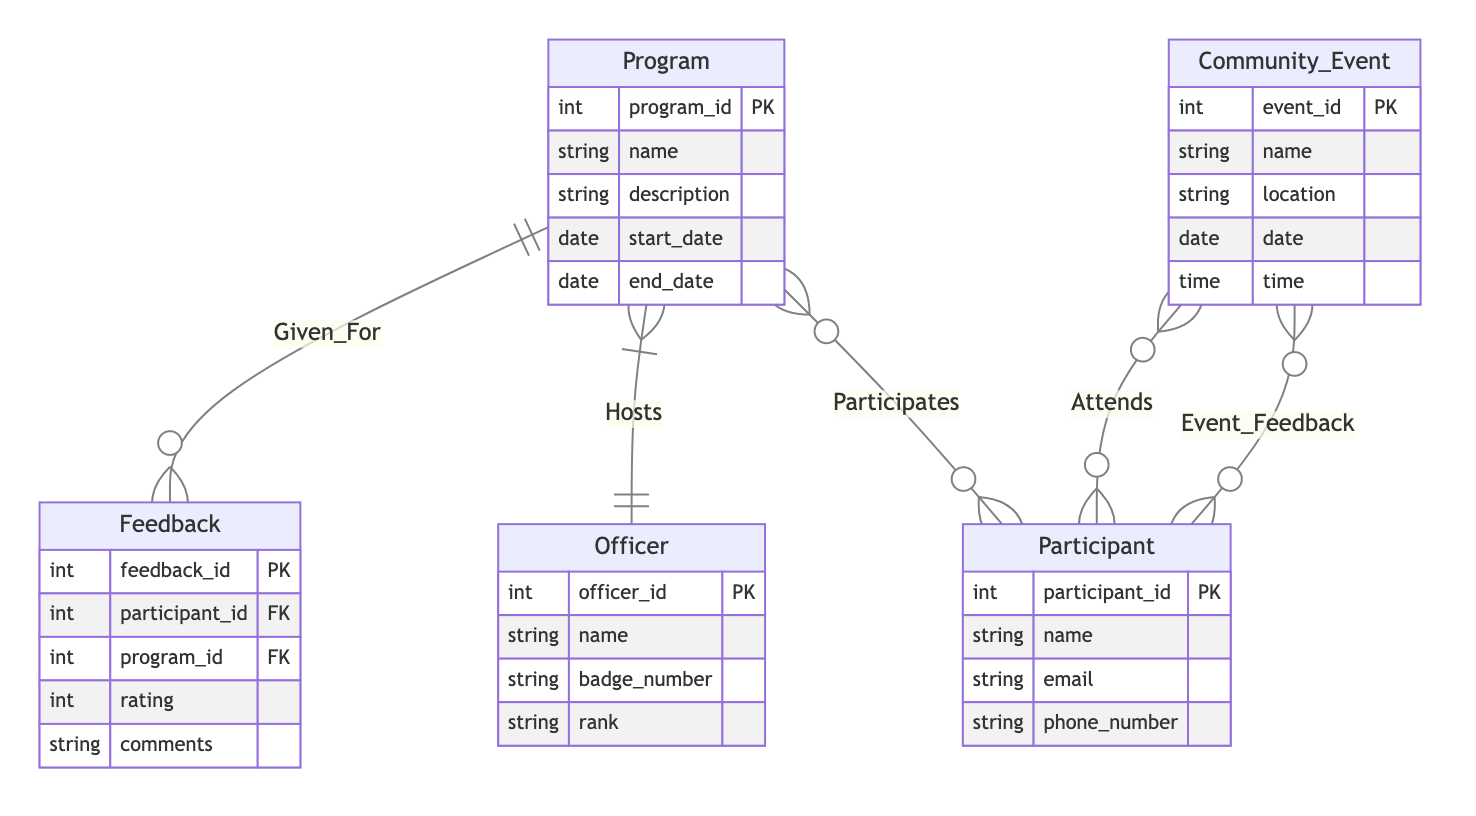What is the cardinality between Officer and Program? The diagram shows a one-to-many relationship from Officer to Program, indicated by the notation "1:N". This means that one Officer can host multiple Programs.
Answer: 1:N How many attributes does the Participant entity have? By examining the Participant entity in the diagram, we can count its attributes: participant_id, name, email, and phone_number, totaling four attributes.
Answer: 4 What relationship connects Participant and Community_Event? The diagram depicts a many-to-many relationship between Participant and Community_Event, represented as "M:N". This implies that a Participant can attend multiple Community_Event instances, and likewise, multiple Participants can attend a single Community_Event.
Answer: M:N How is feedback related to Program? The diagram illustrates that Feedback is given for a Program, represented by the "Given_For" relationship, which indicates a many-to-one association (N:1) from Feedback to Program. This means multiple Feedback entries can be associated with one Program.
Answer: Given_For What is the primary key of the Program entity? The diagram indicates that the primary key for the Program entity is program_id, as denoted by "PK". This unique identifier is used to distinguish each Program entry in the database.
Answer: program_id How many entities are in the diagram? The diagram consists of five entities: Program, Community_Event, Participant, Officer, and Feedback. Counting these provides the total number of entities.
Answer: 5 Which entity is associated with the highest cardinality? The Participant entity is involved in multiple relationships with the highest cardinality, specifically M:N relationships with Community_Event and Program and N:1 with Feedback, meaning a single Participant can have multiple associations.
Answer: Participant What is the relationship between Community_Event and Participant for feedback? The relationship between Community_Event and Participant regarding feedback is marked as Event_Feedback, which is a many-to-many relationship (M:N), indicating that Participants can give feedback for multiple Community_Events.
Answer: Event_Feedback 